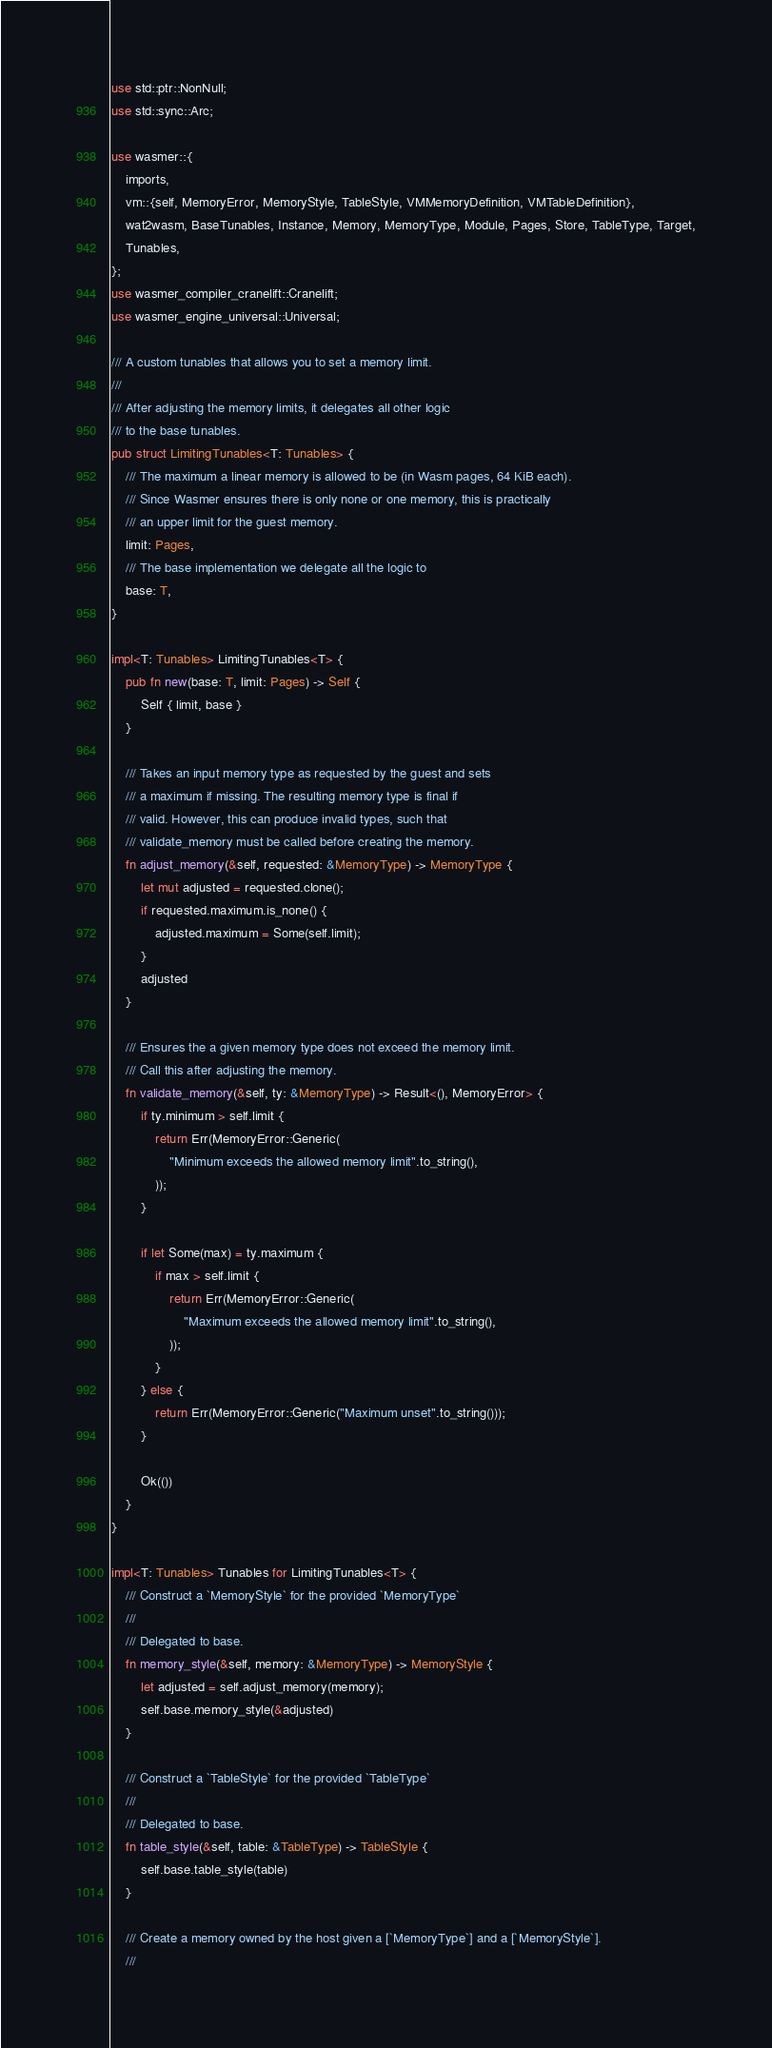<code> <loc_0><loc_0><loc_500><loc_500><_Rust_>use std::ptr::NonNull;
use std::sync::Arc;

use wasmer::{
    imports,
    vm::{self, MemoryError, MemoryStyle, TableStyle, VMMemoryDefinition, VMTableDefinition},
    wat2wasm, BaseTunables, Instance, Memory, MemoryType, Module, Pages, Store, TableType, Target,
    Tunables,
};
use wasmer_compiler_cranelift::Cranelift;
use wasmer_engine_universal::Universal;

/// A custom tunables that allows you to set a memory limit.
///
/// After adjusting the memory limits, it delegates all other logic
/// to the base tunables.
pub struct LimitingTunables<T: Tunables> {
    /// The maximum a linear memory is allowed to be (in Wasm pages, 64 KiB each).
    /// Since Wasmer ensures there is only none or one memory, this is practically
    /// an upper limit for the guest memory.
    limit: Pages,
    /// The base implementation we delegate all the logic to
    base: T,
}

impl<T: Tunables> LimitingTunables<T> {
    pub fn new(base: T, limit: Pages) -> Self {
        Self { limit, base }
    }

    /// Takes an input memory type as requested by the guest and sets
    /// a maximum if missing. The resulting memory type is final if
    /// valid. However, this can produce invalid types, such that
    /// validate_memory must be called before creating the memory.
    fn adjust_memory(&self, requested: &MemoryType) -> MemoryType {
        let mut adjusted = requested.clone();
        if requested.maximum.is_none() {
            adjusted.maximum = Some(self.limit);
        }
        adjusted
    }

    /// Ensures the a given memory type does not exceed the memory limit.
    /// Call this after adjusting the memory.
    fn validate_memory(&self, ty: &MemoryType) -> Result<(), MemoryError> {
        if ty.minimum > self.limit {
            return Err(MemoryError::Generic(
                "Minimum exceeds the allowed memory limit".to_string(),
            ));
        }

        if let Some(max) = ty.maximum {
            if max > self.limit {
                return Err(MemoryError::Generic(
                    "Maximum exceeds the allowed memory limit".to_string(),
                ));
            }
        } else {
            return Err(MemoryError::Generic("Maximum unset".to_string()));
        }

        Ok(())
    }
}

impl<T: Tunables> Tunables for LimitingTunables<T> {
    /// Construct a `MemoryStyle` for the provided `MemoryType`
    ///
    /// Delegated to base.
    fn memory_style(&self, memory: &MemoryType) -> MemoryStyle {
        let adjusted = self.adjust_memory(memory);
        self.base.memory_style(&adjusted)
    }

    /// Construct a `TableStyle` for the provided `TableType`
    ///
    /// Delegated to base.
    fn table_style(&self, table: &TableType) -> TableStyle {
        self.base.table_style(table)
    }

    /// Create a memory owned by the host given a [`MemoryType`] and a [`MemoryStyle`].
    ///</code> 